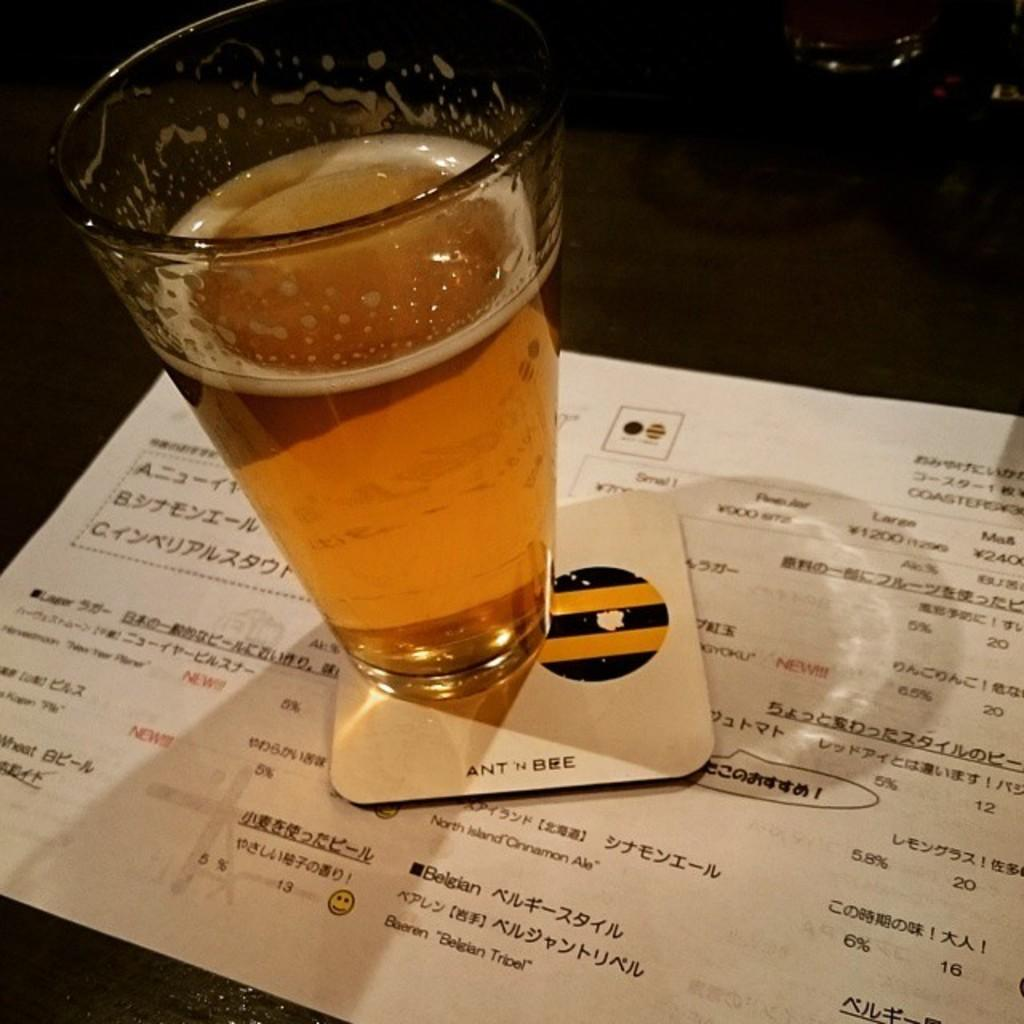What piece of furniture is present in the image? There is a table in the image. What is on the table? There is a glass containing a beverage and a paper on the table. What is placed under the glass to protect the table? There is a coaster on the table. Is there a bear sitting on the table in the image? No, there is no bear present in the image. 